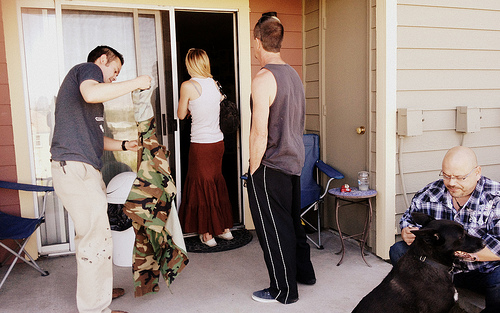<image>
Can you confirm if the man is next to the woman? Yes. The man is positioned adjacent to the woman, located nearby in the same general area. 